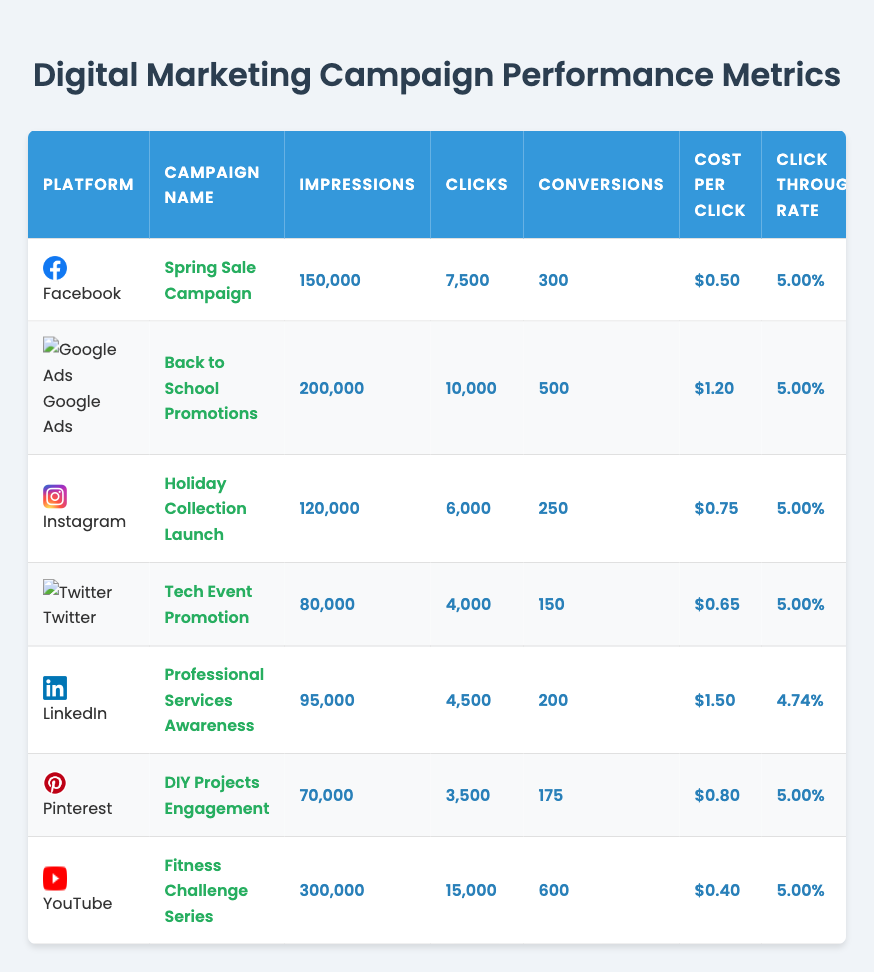What is the total number of impressions across all campaigns? To find the total number of impressions, we sum up the impressions from each campaign: 150,000 (Facebook) + 200,000 (Google Ads) + 120,000 (Instagram) + 80,000 (Twitter) + 95,000 (LinkedIn) + 70,000 (Pinterest) + 300,000 (YouTube) = 1,015,000.
Answer: 1,015,000 Which campaign had the highest conversion rate? Looking through the conversion rates, the rates are: 4.00% (Facebook), 5.00% (Google Ads), 4.17% (Instagram), 3.75% (Twitter), 4.44% (LinkedIn), 5.00% (Pinterest), and 4.00% (YouTube). The highest is 5.00%, which is shared by Google Ads and Pinterest.
Answer: Google Ads and Pinterest What is the average cost per click for all platforms? The costs per click are: $0.50 (Facebook), $1.20 (Google Ads), $0.75 (Instagram), $0.65 (Twitter), $1.50 (LinkedIn), $0.80 (Pinterest), and $0.40 (YouTube). The sum is $0.50 + $1.20 + $0.75 + $0.65 + $1.50 + $0.80 + $0.40 = $5.80. There are 7 platforms, so the average is $5.80 / 7 = $0.82857, which rounds to $0.83.
Answer: $0.83 Did the Twitter campaign generate more conversions than the Pinterest campaign? Twitter had 150 conversions, while Pinterest had 175 conversions. Since 150 is less than 175, Twitter did not generate more conversions than Pinterest.
Answer: No What is the return on ad spend for the Instagram campaign? The return on ad spend for the Instagram campaign is listed as 5.0.
Answer: 5.0 Which platform had the lowest number of impressions? The number of impressions for each platform are: 150,000 (Facebook), 200,000 (Google Ads), 120,000 (Instagram), 80,000 (Twitter), 95,000 (LinkedIn), 70,000 (Pinterest), and 300,000 (YouTube). The lowest number of impressions is 70,000 from Pinterest.
Answer: Pinterest If we combine the conversion rates of Facebook and LinkedIn, what will their average be? The conversion rates are 4.00% (Facebook) and 4.44% (LinkedIn). To find the average, we sum the rates: 4.00% + 4.44% = 8.44%. Then, divide this by 2, so the average is 8.44% / 2 = 4.22%.
Answer: 4.22% Which campaign had the maximum return on ad spend? The return on ad spend values are: 4.5 (Facebook), 3.8 (Google Ads), 5.0 (Instagram), 3.0 (Twitter), 2.5 (LinkedIn), 4.2 (Pinterest), and 6.0 (YouTube). The maximum is 6.0 for YouTube.
Answer: YouTube Is the click-through rate consistent across all platforms? All platforms have a click-through rate of 5.00%, except for LinkedIn, which has 4.74%. Therefore, it is not consistent across all platforms.
Answer: No What campaign had the most clicks generated? The clicks for each campaign are: 7,500 (Facebook), 10,000 (Google Ads), 6,000 (Instagram), 4,000 (Twitter), 4,500 (LinkedIn), 3,500 (Pinterest), and 15,000 (YouTube). The most clicks are 15,000 from YouTube.
Answer: YouTube 